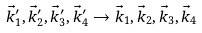<formula> <loc_0><loc_0><loc_500><loc_500>\vec { k } _ { 1 } ^ { \prime } , \vec { k } _ { 2 } ^ { \prime } , \vec { k } _ { 3 } ^ { \prime } , \vec { k } _ { 4 } ^ { \prime } \rightarrow \vec { k } _ { 1 } , \vec { k } _ { 2 } , \vec { k } _ { 3 } , \vec { k } _ { 4 }</formula> 